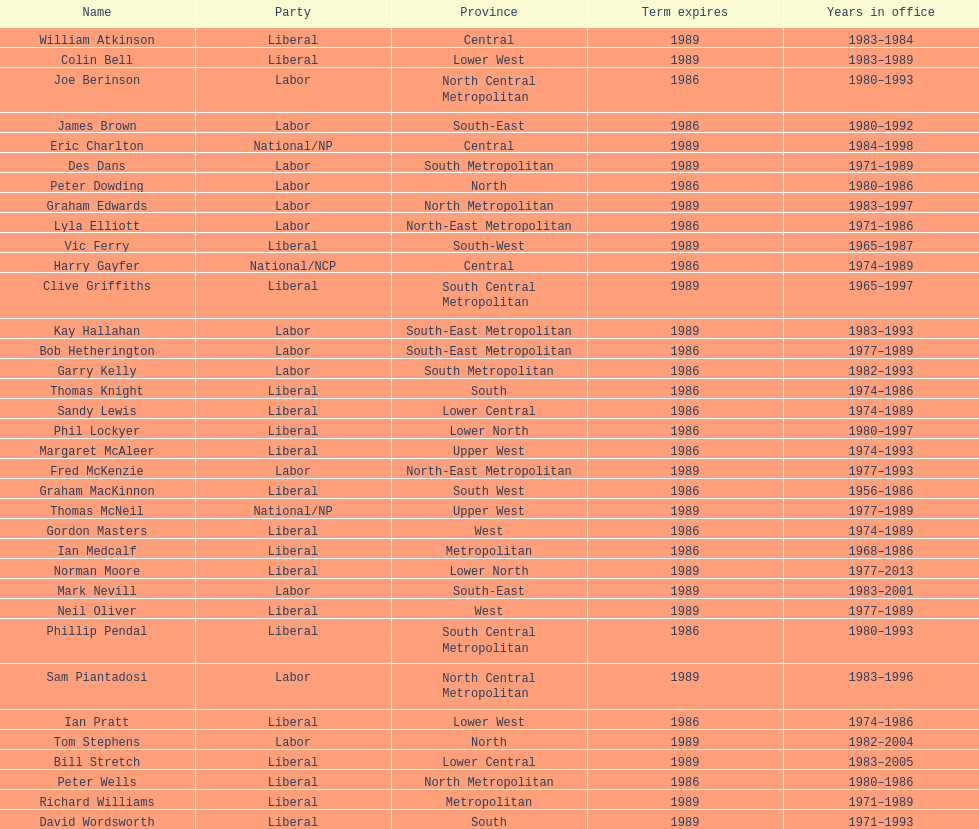Hame the last member listed whose last name begins with "p". Ian Pratt. 